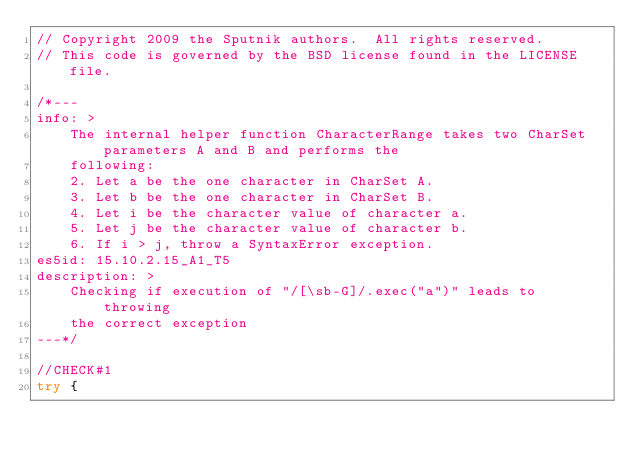Convert code to text. <code><loc_0><loc_0><loc_500><loc_500><_JavaScript_>// Copyright 2009 the Sputnik authors.  All rights reserved.
// This code is governed by the BSD license found in the LICENSE file.

/*---
info: >
    The internal helper function CharacterRange takes two CharSet parameters A and B and performs the
    following:
    2. Let a be the one character in CharSet A.
    3. Let b be the one character in CharSet B.
    4. Let i be the character value of character a.
    5. Let j be the character value of character b.
    6. If i > j, throw a SyntaxError exception.
es5id: 15.10.2.15_A1_T5
description: >
    Checking if execution of "/[\sb-G]/.exec("a")" leads to throwing
    the correct exception
---*/

//CHECK#1
try {</code> 